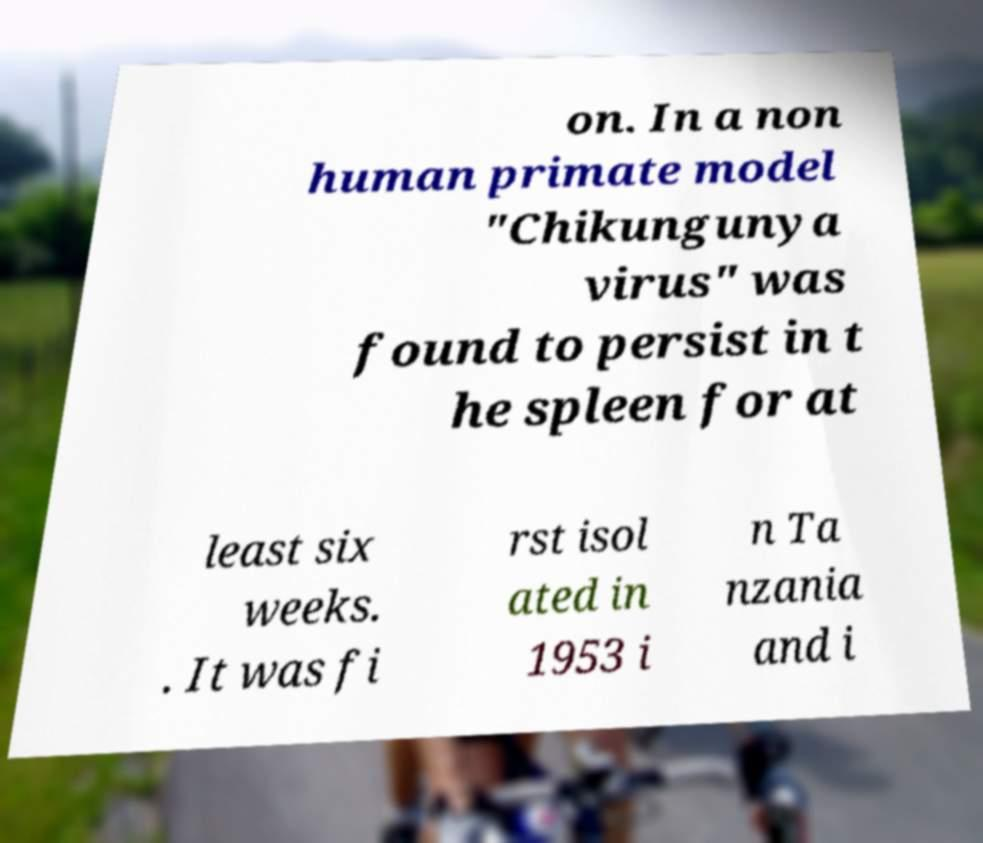Please read and relay the text visible in this image. What does it say? on. In a non human primate model "Chikungunya virus" was found to persist in t he spleen for at least six weeks. . It was fi rst isol ated in 1953 i n Ta nzania and i 